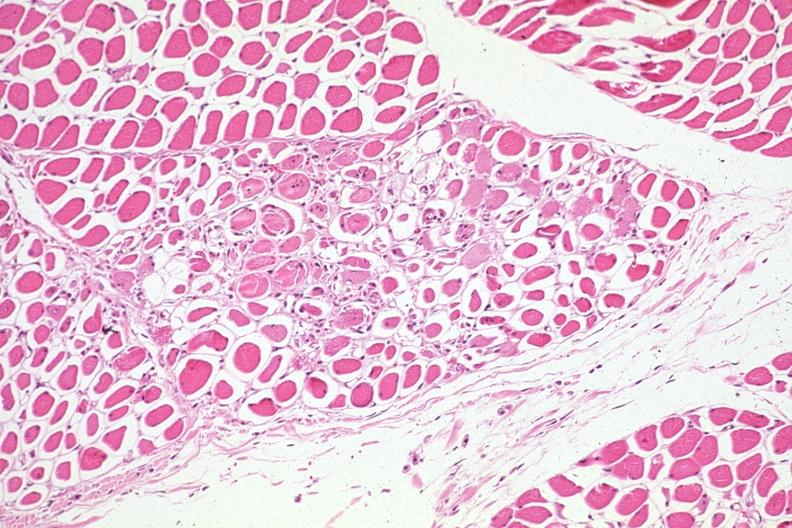s soft tissue present?
Answer the question using a single word or phrase. Yes 